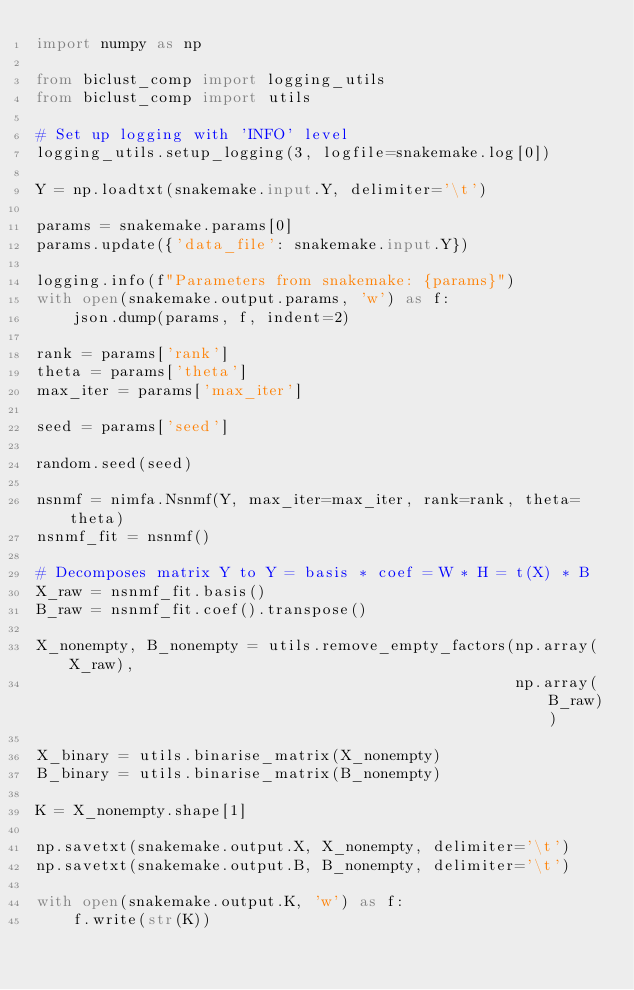Convert code to text. <code><loc_0><loc_0><loc_500><loc_500><_Python_>import numpy as np

from biclust_comp import logging_utils
from biclust_comp import utils

# Set up logging with 'INFO' level
logging_utils.setup_logging(3, logfile=snakemake.log[0])

Y = np.loadtxt(snakemake.input.Y, delimiter='\t')

params = snakemake.params[0]
params.update({'data_file': snakemake.input.Y})

logging.info(f"Parameters from snakemake: {params}")
with open(snakemake.output.params, 'w') as f:
    json.dump(params, f, indent=2)

rank = params['rank']
theta = params['theta']
max_iter = params['max_iter']

seed = params['seed']

random.seed(seed)

nsnmf = nimfa.Nsnmf(Y, max_iter=max_iter, rank=rank, theta=theta)
nsnmf_fit = nsnmf()

# Decomposes matrix Y to Y = basis * coef = W * H = t(X) * B
X_raw = nsnmf_fit.basis()
B_raw = nsnmf_fit.coef().transpose()

X_nonempty, B_nonempty = utils.remove_empty_factors(np.array(X_raw),
                                                    np.array(B_raw))

X_binary = utils.binarise_matrix(X_nonempty)
B_binary = utils.binarise_matrix(B_nonempty)

K = X_nonempty.shape[1]

np.savetxt(snakemake.output.X, X_nonempty, delimiter='\t')
np.savetxt(snakemake.output.B, B_nonempty, delimiter='\t')

with open(snakemake.output.K, 'w') as f:
    f.write(str(K))
</code> 